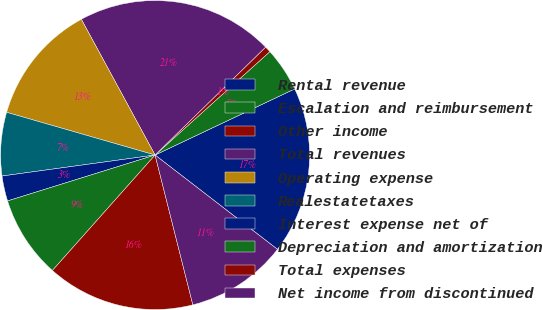Convert chart. <chart><loc_0><loc_0><loc_500><loc_500><pie_chart><fcel>Rental revenue<fcel>Escalation and reimbursement<fcel>Other income<fcel>Total revenues<fcel>Operating expense<fcel>Realestatetaxes<fcel>Interest expense net of<fcel>Depreciation and amortization<fcel>Total expenses<fcel>Net income from discontinued<nl><fcel>17.49%<fcel>4.63%<fcel>0.64%<fcel>20.61%<fcel>12.62%<fcel>6.63%<fcel>2.63%<fcel>8.63%<fcel>15.5%<fcel>10.62%<nl></chart> 